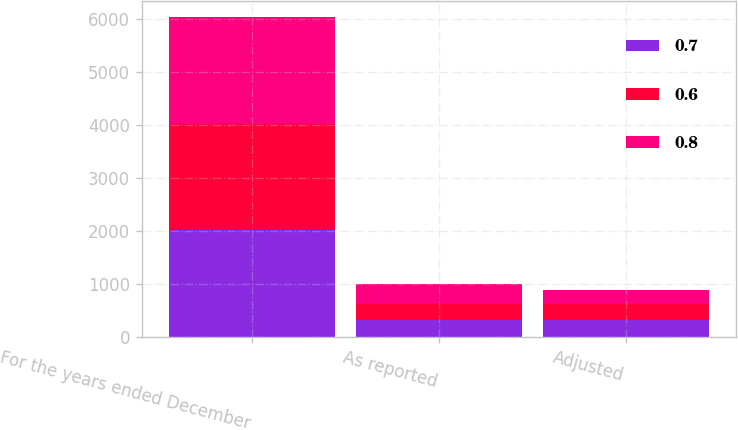<chart> <loc_0><loc_0><loc_500><loc_500><stacked_bar_chart><ecel><fcel>For the years ended December<fcel>As reported<fcel>Adjusted<nl><fcel>0.7<fcel>2016<fcel>330.1<fcel>330.1<nl><fcel>0.6<fcel>2015<fcel>299.3<fcel>294.1<nl><fcel>0.8<fcel>2014<fcel>375.8<fcel>272.6<nl></chart> 